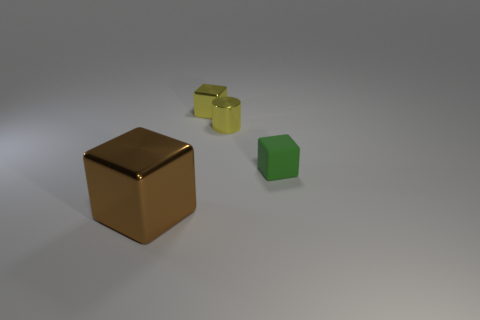Subtract 1 cubes. How many cubes are left? 2 Add 2 green rubber blocks. How many objects exist? 6 Subtract all blocks. How many objects are left? 1 Add 2 large brown metallic blocks. How many large brown metallic blocks exist? 3 Subtract 0 purple blocks. How many objects are left? 4 Subtract all small yellow matte things. Subtract all tiny yellow metal cubes. How many objects are left? 3 Add 2 large brown metallic things. How many large brown metallic things are left? 3 